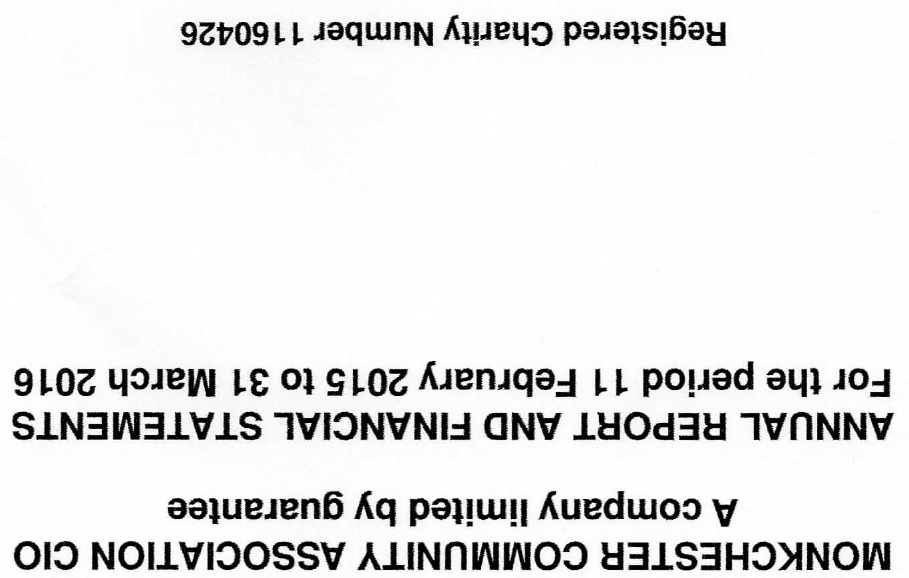What is the value for the address__post_town?
Answer the question using a single word or phrase. NEWCASTLE UPON TYNE 